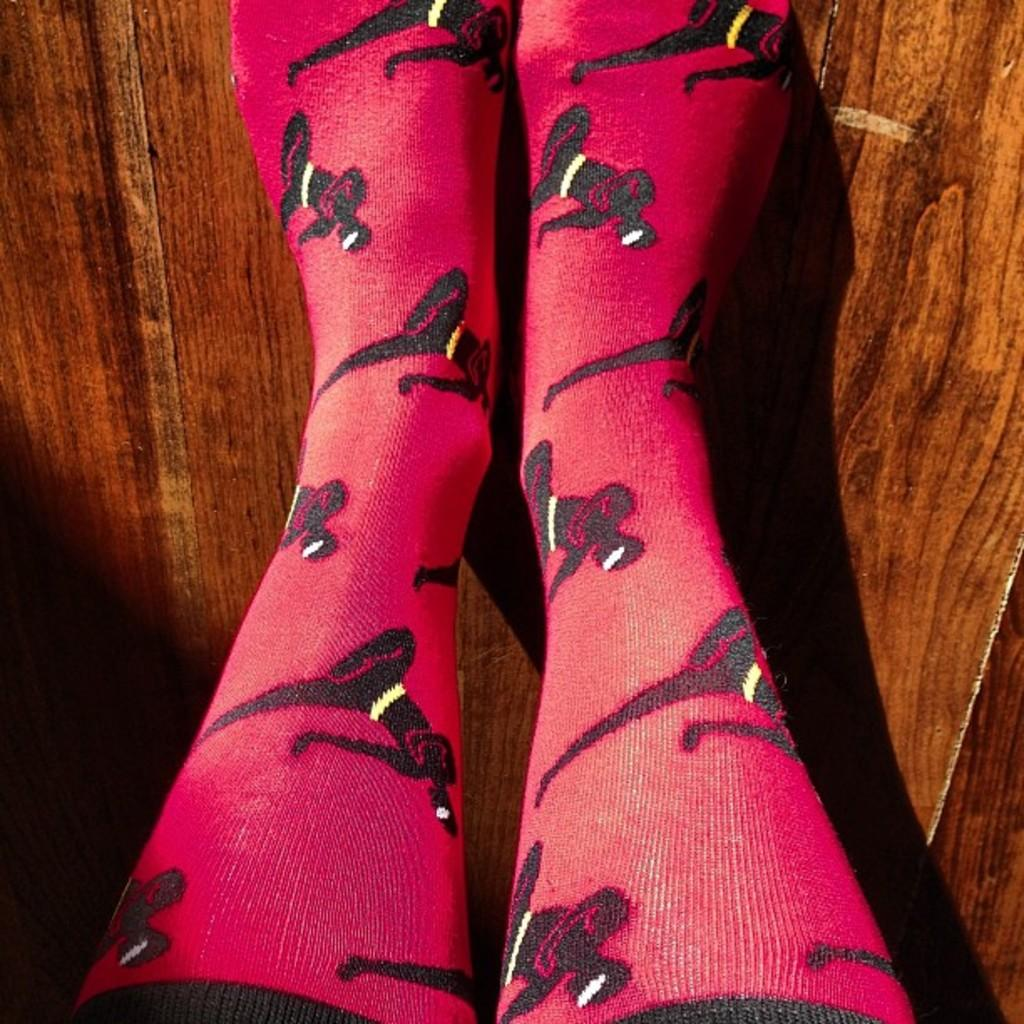What part of a person's body is visible in the image? There are legs of a person visible in the image. What type of surface is the person's legs resting on? The legs are on a wooden surface. What type of event is taking place in the image? There is no indication of any event taking place in the image. Can you see a bell in the image? There is no bell present in the image. What is the top of the image showing? The provided facts do not mention anything about the top of the image. 